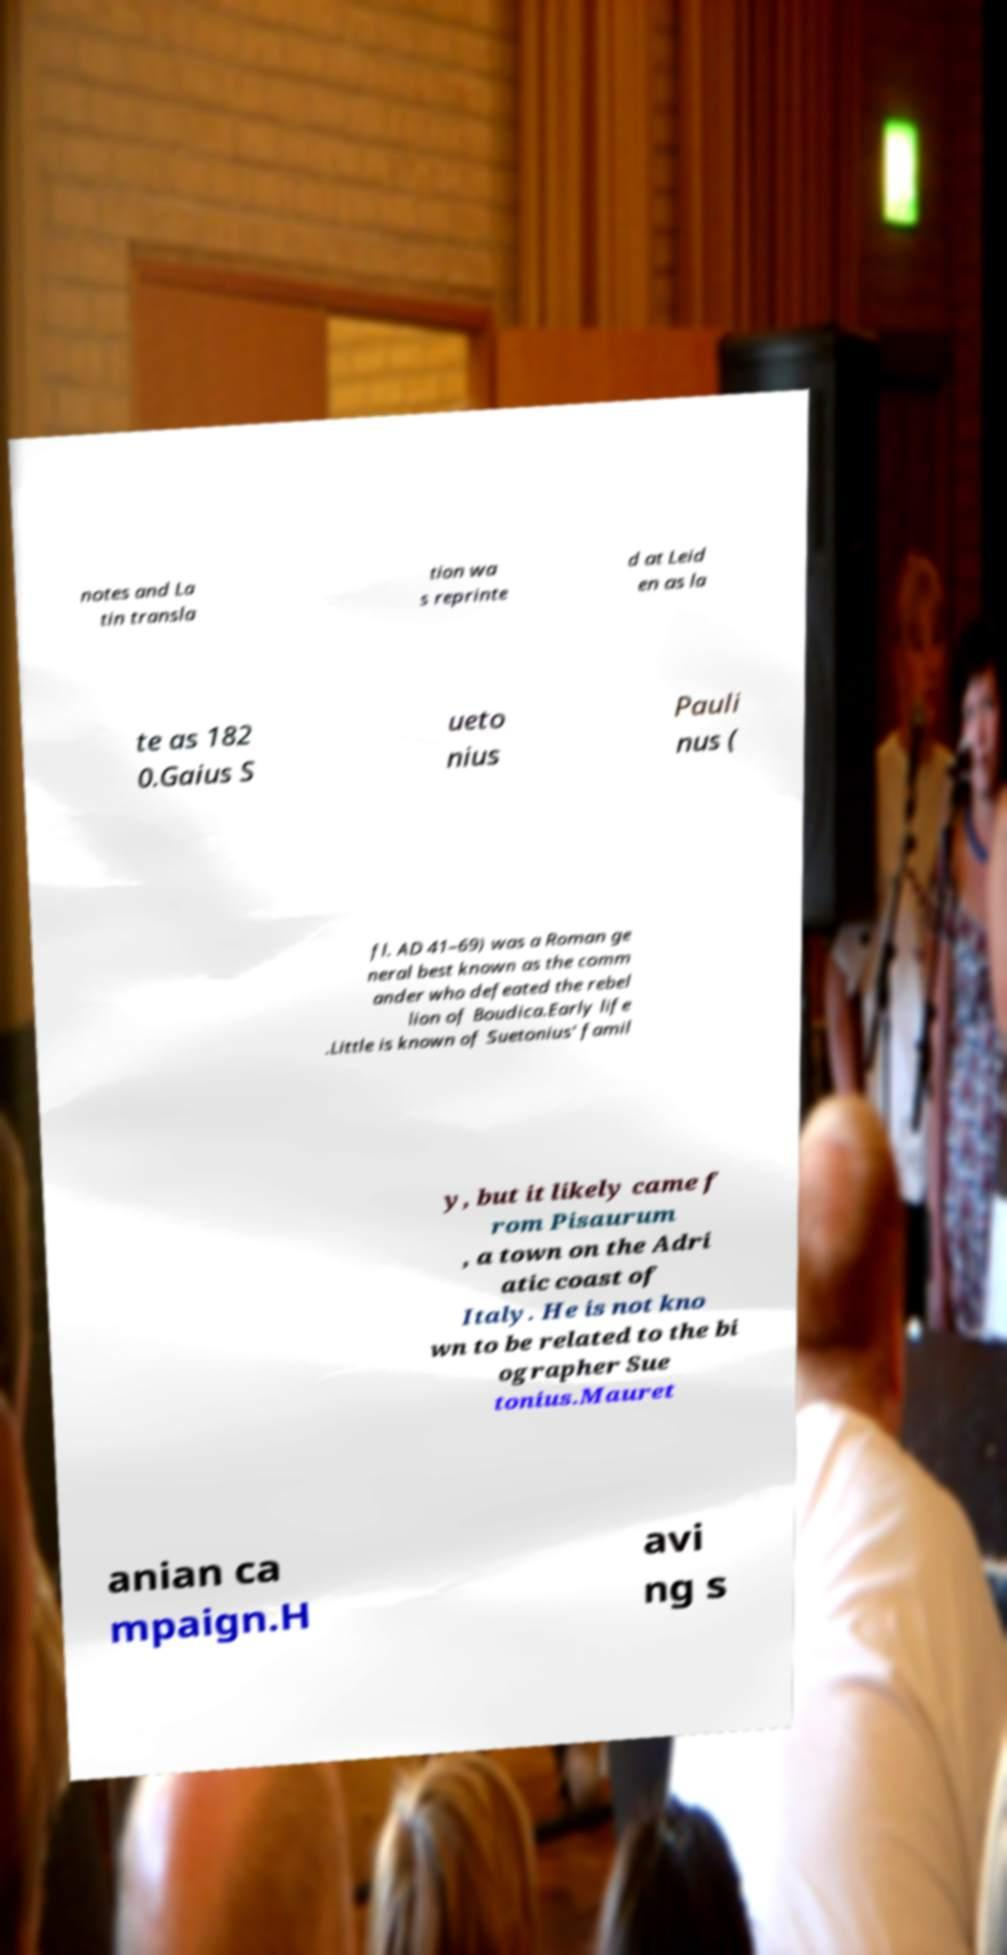Please identify and transcribe the text found in this image. notes and La tin transla tion wa s reprinte d at Leid en as la te as 182 0.Gaius S ueto nius Pauli nus ( fl. AD 41–69) was a Roman ge neral best known as the comm ander who defeated the rebel lion of Boudica.Early life .Little is known of Suetonius' famil y, but it likely came f rom Pisaurum , a town on the Adri atic coast of Italy. He is not kno wn to be related to the bi ographer Sue tonius.Mauret anian ca mpaign.H avi ng s 